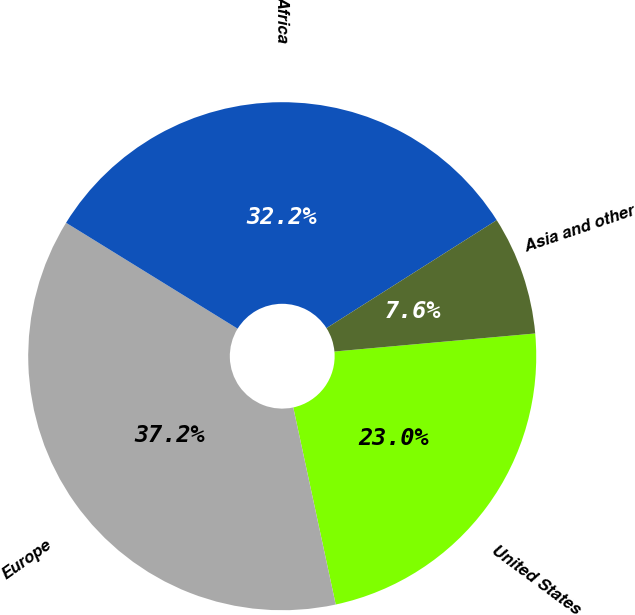Convert chart to OTSL. <chart><loc_0><loc_0><loc_500><loc_500><pie_chart><fcel>United States<fcel>Europe<fcel>Africa<fcel>Asia and other<nl><fcel>23.05%<fcel>37.18%<fcel>32.2%<fcel>7.57%<nl></chart> 